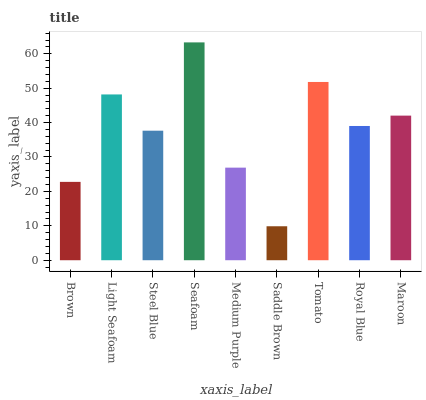Is Saddle Brown the minimum?
Answer yes or no. Yes. Is Seafoam the maximum?
Answer yes or no. Yes. Is Light Seafoam the minimum?
Answer yes or no. No. Is Light Seafoam the maximum?
Answer yes or no. No. Is Light Seafoam greater than Brown?
Answer yes or no. Yes. Is Brown less than Light Seafoam?
Answer yes or no. Yes. Is Brown greater than Light Seafoam?
Answer yes or no. No. Is Light Seafoam less than Brown?
Answer yes or no. No. Is Royal Blue the high median?
Answer yes or no. Yes. Is Royal Blue the low median?
Answer yes or no. Yes. Is Brown the high median?
Answer yes or no. No. Is Light Seafoam the low median?
Answer yes or no. No. 